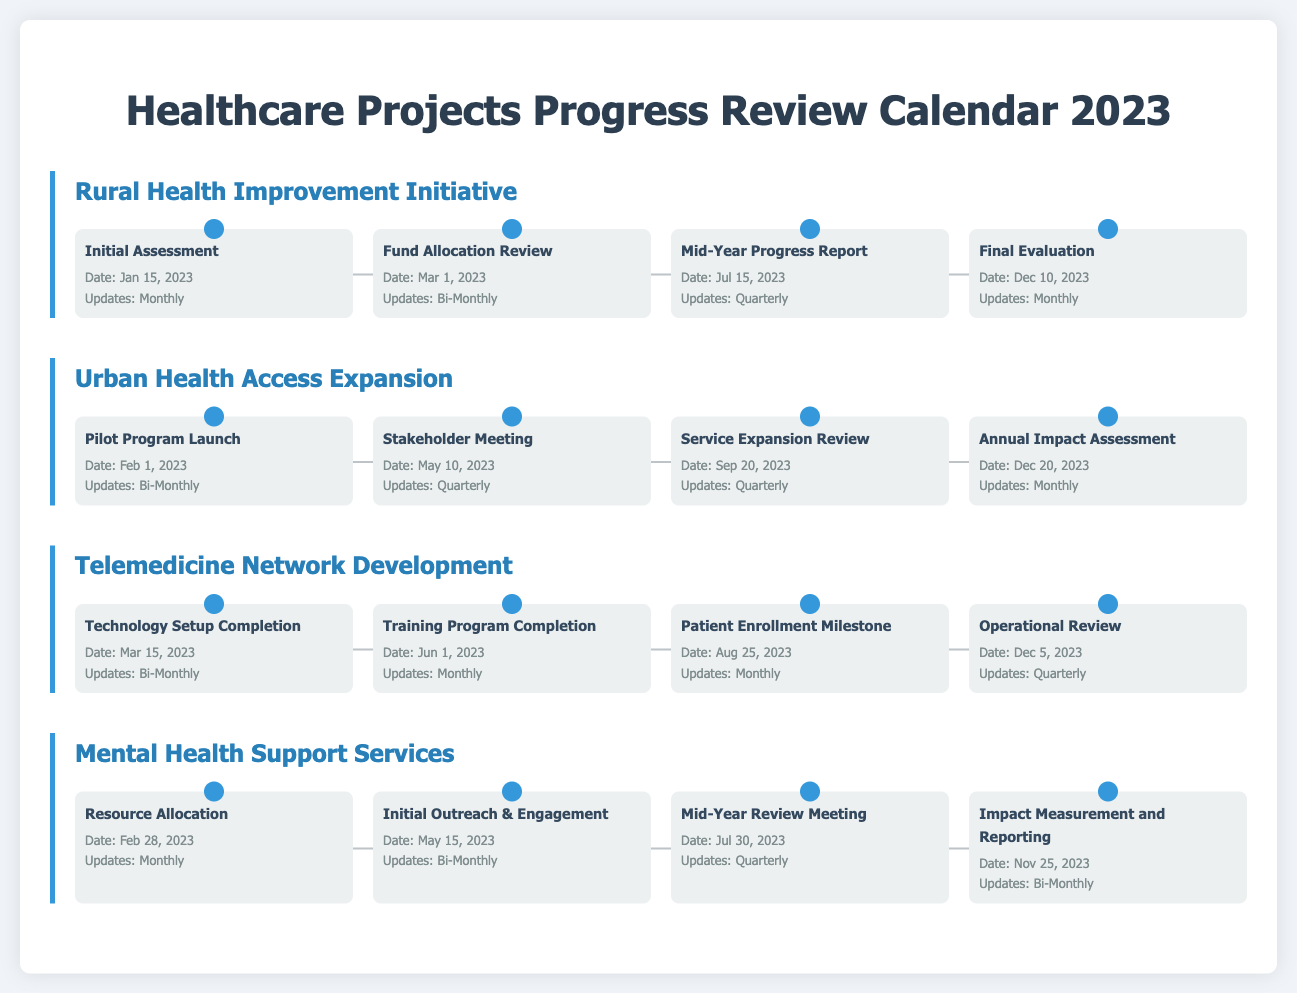what is the date of the Initial Assessment for the Rural Health Improvement Initiative? The Initial Assessment is scheduled for January 15, 2023 as indicated in the document.
Answer: January 15, 2023 how often are updates provided for the Mid-Year Progress Report? The document specifies that updates for the Mid-Year Progress Report are quarterly.
Answer: Quarterly what is the last milestone date for the Telemedicine Network Development? The final milestone listed for Telemedicine Network Development is on December 5, 2023 as shown in the timeline.
Answer: December 5, 2023 which project has its Annual Impact Assessment scheduled for December 20, 2023? The document indicates that the Annual Impact Assessment is for the Urban Health Access Expansion project.
Answer: Urban Health Access Expansion how many milestones does the Mental Health Support Services project have listed? The document outlines four milestones for the Mental Health Support Services project.
Answer: Four when is the Service Expansion Review planned? The Service Expansion Review is set for September 20, 2023 according to the document.
Answer: September 20, 2023 what type of updates are provided for the Resource Allocation milestone? Resource Allocation updates are provided monthly as stated in the document.
Answer: Monthly what is the purpose of the Stakeholder Meeting in the Urban Health Access Expansion project? The Stakeholder Meeting is a milestone focused on engaging stakeholders as per the project outline.
Answer: Engagement how often does the Telemedicine Network Development project provide updates for the Training Program Completion? Updates for Training Program Completion occur monthly according to the document.
Answer: Monthly 